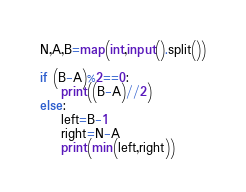Convert code to text. <code><loc_0><loc_0><loc_500><loc_500><_Python_>N,A,B=map(int,input().split())

if (B-A)%2==0:
    print((B-A)//2)
else:
    left=B-1
    right=N-A
    print(min(left,right))</code> 